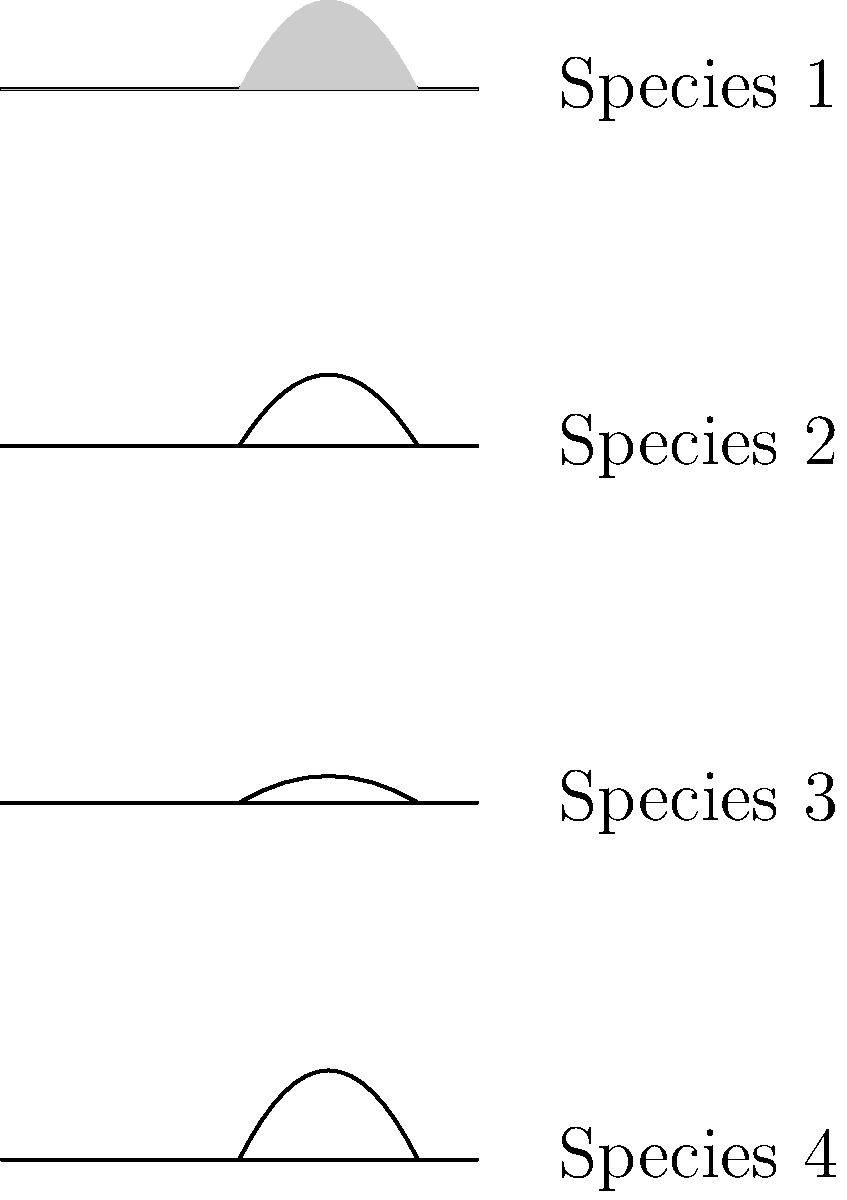Based on the silhouettes of four catfish species found in African rivers, which species is likely to be the most efficient swimmer in fast-flowing water? To determine which species is likely to be the most efficient swimmer in fast-flowing water, we need to consider the body shapes of the catfish:

1. Species 1: Moderately streamlined body with a slight curve.
2. Species 2: More curved body shape with a higher back.
3. Species 3: Slender, streamlined body with minimal curvature.
4. Species 4: Highly curved body shape with a pronounced arch.

In fast-flowing water, the most efficient swimmers typically have:
a) Streamlined bodies to reduce drag
b) Minimal body curvature to maintain stability

Step-by-step analysis:
1. Species 1 and 3 have more streamlined bodies compared to Species 2 and 4.
2. Species 3 has the least curvature, making it the most hydrodynamic.
3. Species 2 and 4 have higher body curvatures, which would increase drag in fast-flowing water.
4. Species 1 has a slight curve but is still relatively streamlined.

Considering these factors, Species 3 is likely to be the most efficient swimmer in fast-flowing water due to its slender, streamlined body with minimal curvature. This shape would minimize drag and allow the fish to navigate fast-flowing rivers with less energy expenditure.
Answer: Species 3 